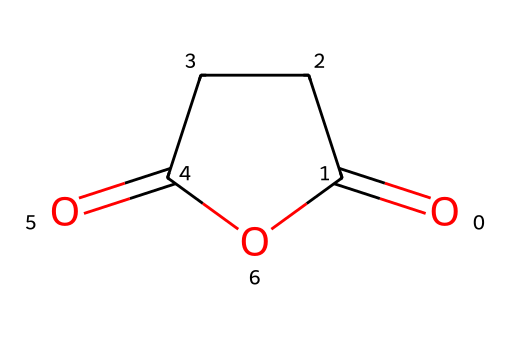What is the molecular formula of succinic anhydride? In the structure provided, we can count 4 carbon atoms (C), 4 oxygen atoms (O), and 6 hydrogen atoms (H). Thus, the molecular formula is derived from counting these atoms.
Answer: C4H4O3 How many rings are present in the chemical structure? Analyzing the structure, there is a cyclic arrangement indicated by the '1' in the SMILES, which shows that it is a cyclic compound. Therefore, there is one ring in the structure.
Answer: 1 What functional group is primarily represented in succinic anhydride? A careful examination reveals the presence of an anhydride group, characterized by the two carbonyl (C=O) groups connected through the cyclic structure, indicating its classification as an anhydride.
Answer: anhydride What type of reaction can succinic anhydride undergo? As an anhydride, succinic anhydride is reactive and can undergo hydrolysis to form the corresponding dicarboxylic acid, succinic acid, when reacted with water.
Answer: hydrolysis How many double bonds are present in the chemical structure? Observing the structure, there are two carbonyl groups (C=O), each representing a double bond between carbon and oxygen. Therefore, the count shows two double bonds are present.
Answer: 2 Is succinic anhydride soluble in water? Given that it's an acid anhydride, succinic anhydride displays a limited solubility in water due to its non-polar character, despite forming acidic products upon reaction.
Answer: limited 